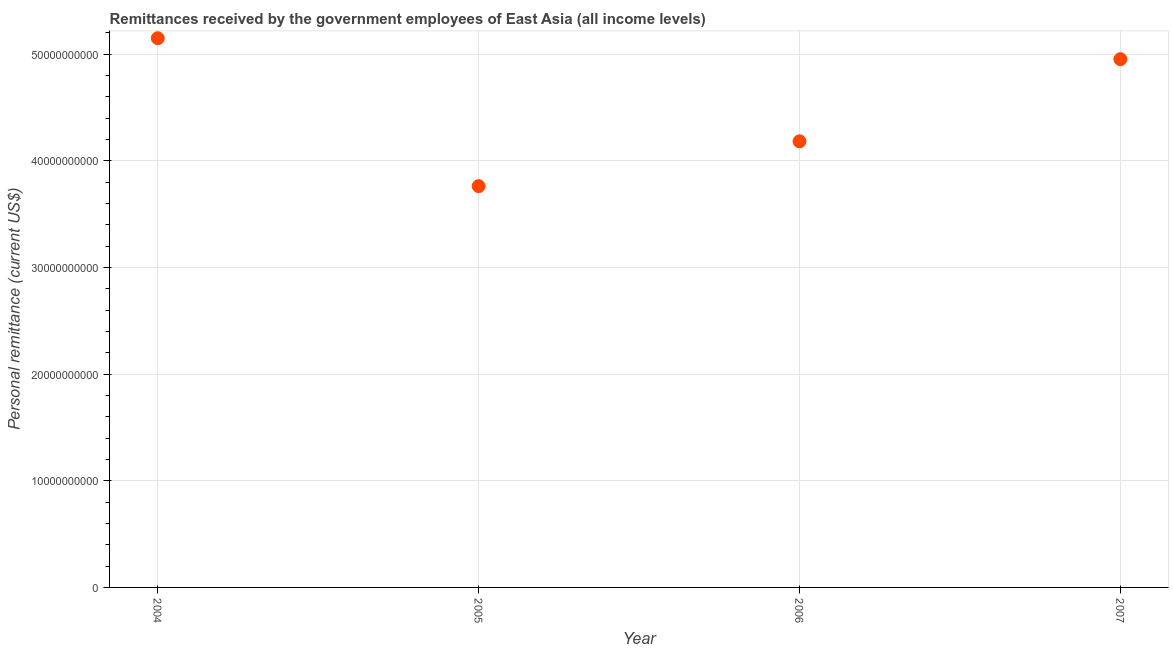What is the personal remittances in 2007?
Give a very brief answer. 4.95e+1. Across all years, what is the maximum personal remittances?
Your answer should be very brief. 5.15e+1. Across all years, what is the minimum personal remittances?
Give a very brief answer. 3.76e+1. In which year was the personal remittances maximum?
Provide a succinct answer. 2004. In which year was the personal remittances minimum?
Offer a very short reply. 2005. What is the sum of the personal remittances?
Offer a very short reply. 1.80e+11. What is the difference between the personal remittances in 2005 and 2006?
Ensure brevity in your answer.  -4.20e+09. What is the average personal remittances per year?
Give a very brief answer. 4.51e+1. What is the median personal remittances?
Provide a succinct answer. 4.57e+1. In how many years, is the personal remittances greater than 16000000000 US$?
Provide a short and direct response. 4. Do a majority of the years between 2006 and 2007 (inclusive) have personal remittances greater than 42000000000 US$?
Your answer should be compact. No. What is the ratio of the personal remittances in 2004 to that in 2006?
Offer a terse response. 1.23. Is the difference between the personal remittances in 2004 and 2007 greater than the difference between any two years?
Your answer should be very brief. No. What is the difference between the highest and the second highest personal remittances?
Your answer should be very brief. 1.96e+09. Is the sum of the personal remittances in 2005 and 2006 greater than the maximum personal remittances across all years?
Provide a short and direct response. Yes. What is the difference between the highest and the lowest personal remittances?
Provide a short and direct response. 1.39e+1. Does the personal remittances monotonically increase over the years?
Keep it short and to the point. No. How many dotlines are there?
Your response must be concise. 1. How many years are there in the graph?
Ensure brevity in your answer.  4. What is the difference between two consecutive major ticks on the Y-axis?
Ensure brevity in your answer.  1.00e+1. Are the values on the major ticks of Y-axis written in scientific E-notation?
Ensure brevity in your answer.  No. What is the title of the graph?
Provide a succinct answer. Remittances received by the government employees of East Asia (all income levels). What is the label or title of the X-axis?
Provide a short and direct response. Year. What is the label or title of the Y-axis?
Provide a succinct answer. Personal remittance (current US$). What is the Personal remittance (current US$) in 2004?
Keep it short and to the point. 5.15e+1. What is the Personal remittance (current US$) in 2005?
Ensure brevity in your answer.  3.76e+1. What is the Personal remittance (current US$) in 2006?
Keep it short and to the point. 4.18e+1. What is the Personal remittance (current US$) in 2007?
Your answer should be very brief. 4.95e+1. What is the difference between the Personal remittance (current US$) in 2004 and 2005?
Offer a terse response. 1.39e+1. What is the difference between the Personal remittance (current US$) in 2004 and 2006?
Your response must be concise. 9.66e+09. What is the difference between the Personal remittance (current US$) in 2004 and 2007?
Your answer should be compact. 1.96e+09. What is the difference between the Personal remittance (current US$) in 2005 and 2006?
Your answer should be very brief. -4.20e+09. What is the difference between the Personal remittance (current US$) in 2005 and 2007?
Offer a terse response. -1.19e+1. What is the difference between the Personal remittance (current US$) in 2006 and 2007?
Your answer should be compact. -7.70e+09. What is the ratio of the Personal remittance (current US$) in 2004 to that in 2005?
Your answer should be very brief. 1.37. What is the ratio of the Personal remittance (current US$) in 2004 to that in 2006?
Provide a succinct answer. 1.23. What is the ratio of the Personal remittance (current US$) in 2004 to that in 2007?
Your answer should be very brief. 1.04. What is the ratio of the Personal remittance (current US$) in 2005 to that in 2006?
Provide a succinct answer. 0.9. What is the ratio of the Personal remittance (current US$) in 2005 to that in 2007?
Make the answer very short. 0.76. What is the ratio of the Personal remittance (current US$) in 2006 to that in 2007?
Provide a short and direct response. 0.84. 